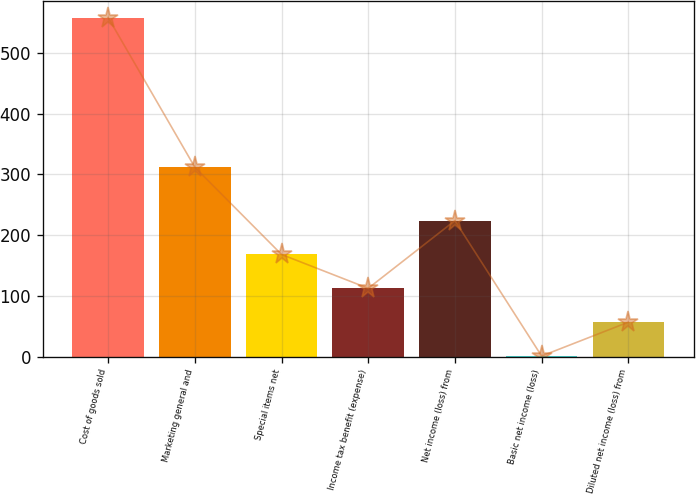Convert chart to OTSL. <chart><loc_0><loc_0><loc_500><loc_500><bar_chart><fcel>Cost of goods sold<fcel>Marketing general and<fcel>Special items net<fcel>Income tax benefit (expense)<fcel>Net income (loss) from<fcel>Basic net income (loss)<fcel>Diluted net income (loss) from<nl><fcel>558.1<fcel>311.6<fcel>168.02<fcel>112.29<fcel>223.75<fcel>0.83<fcel>56.56<nl></chart> 